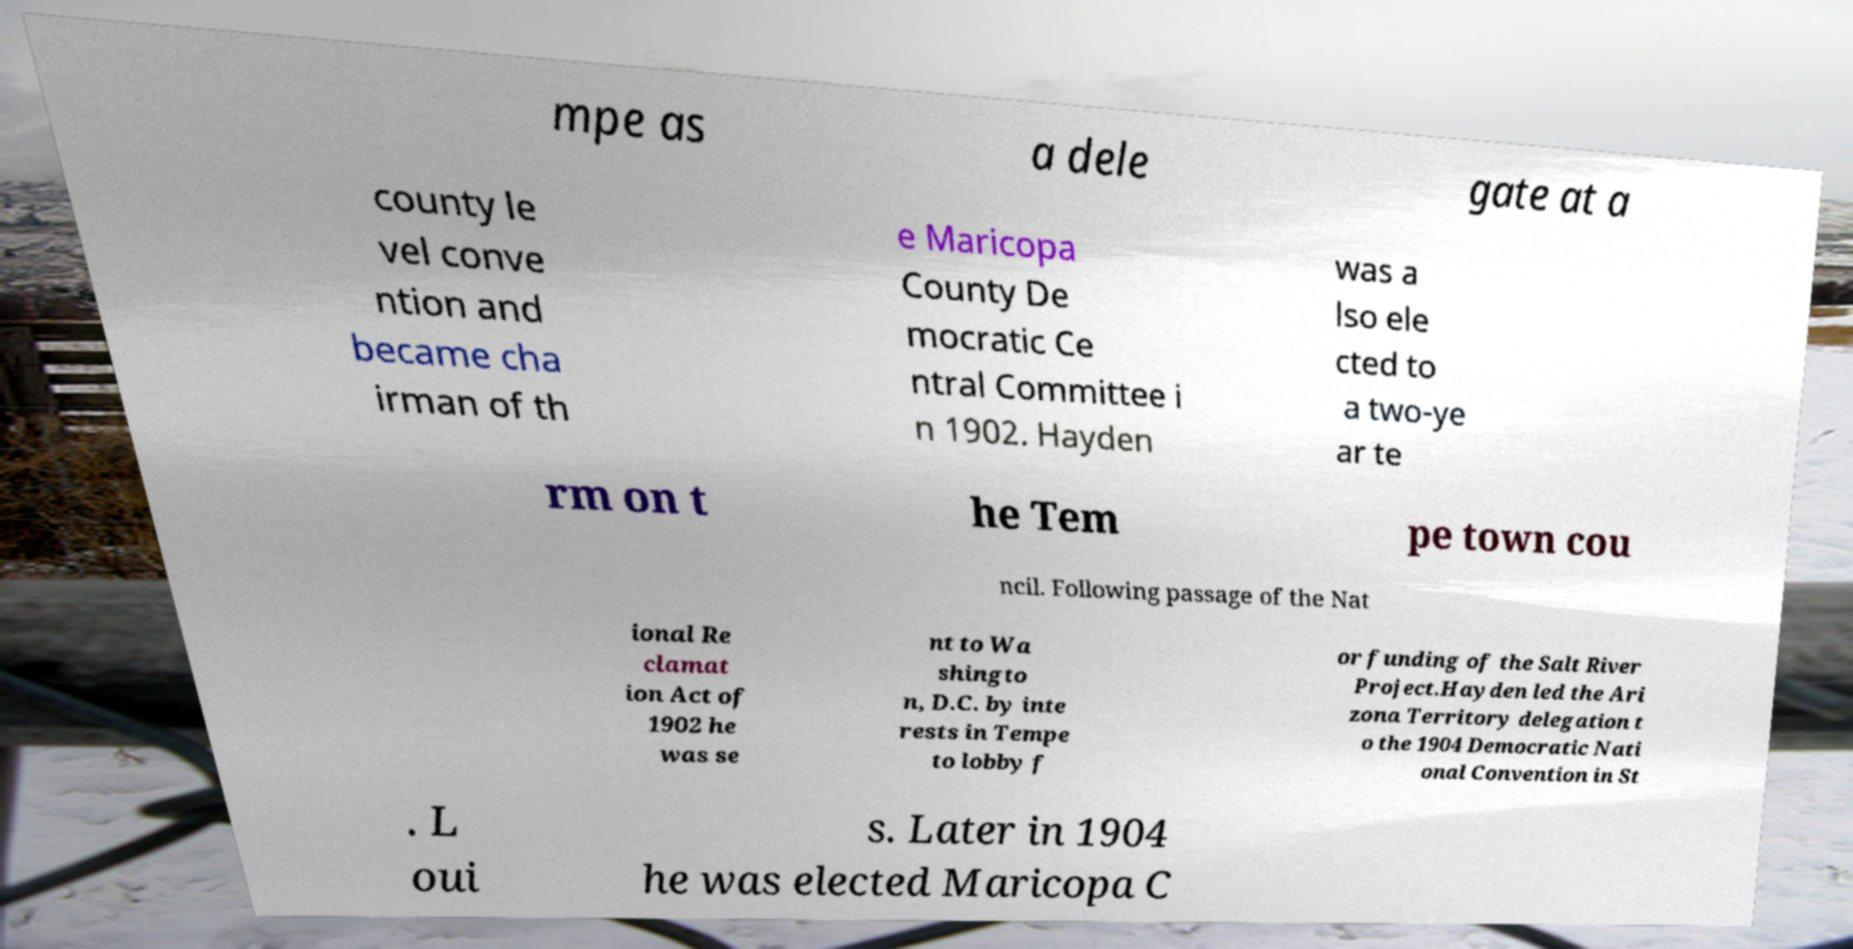What messages or text are displayed in this image? I need them in a readable, typed format. mpe as a dele gate at a county le vel conve ntion and became cha irman of th e Maricopa County De mocratic Ce ntral Committee i n 1902. Hayden was a lso ele cted to a two-ye ar te rm on t he Tem pe town cou ncil. Following passage of the Nat ional Re clamat ion Act of 1902 he was se nt to Wa shingto n, D.C. by inte rests in Tempe to lobby f or funding of the Salt River Project.Hayden led the Ari zona Territory delegation t o the 1904 Democratic Nati onal Convention in St . L oui s. Later in 1904 he was elected Maricopa C 